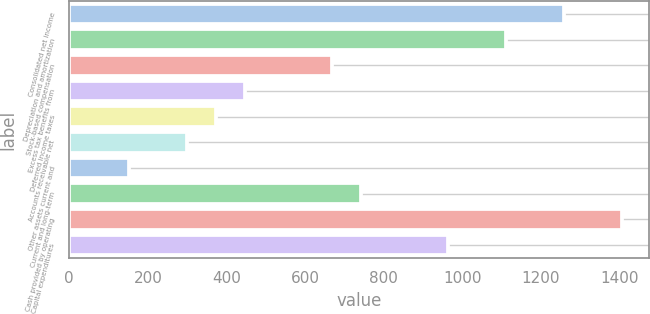<chart> <loc_0><loc_0><loc_500><loc_500><bar_chart><fcel>Consolidated net income<fcel>Depreciation and amortization<fcel>Stock-based compensation<fcel>Excess tax benefits from<fcel>Deferred income taxes<fcel>Accounts receivable net<fcel>Other assets current and<fcel>Current and long-term<fcel>Cash provided by operating<fcel>Capital expenditures<nl><fcel>1258.49<fcel>1110.95<fcel>668.33<fcel>447.02<fcel>373.25<fcel>299.48<fcel>151.94<fcel>742.1<fcel>1406.03<fcel>963.41<nl></chart> 